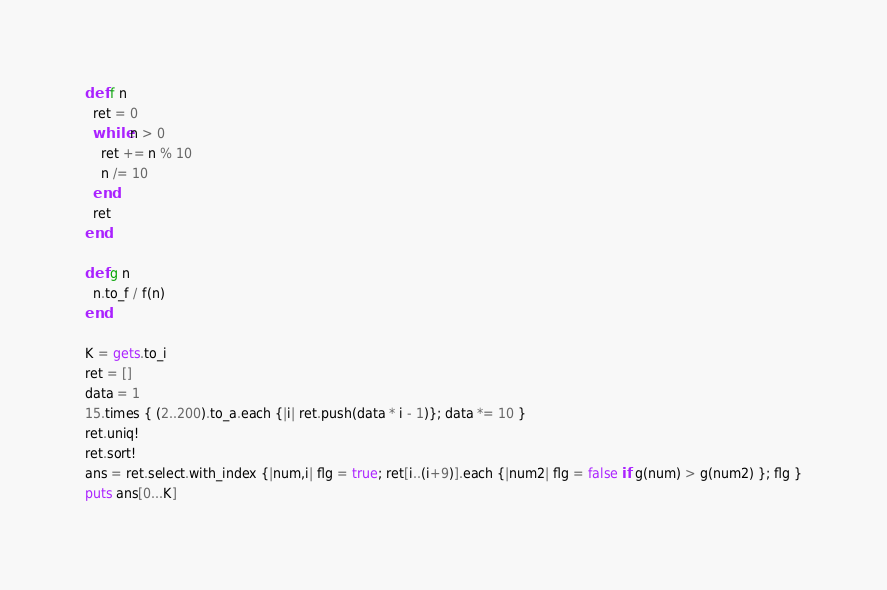Convert code to text. <code><loc_0><loc_0><loc_500><loc_500><_Ruby_>def f n
  ret = 0
  while n > 0
    ret += n % 10
    n /= 10
  end
  ret
end

def g n
  n.to_f / f(n)
end

K = gets.to_i
ret = []
data = 1
15.times { (2..200).to_a.each {|i| ret.push(data * i - 1)}; data *= 10 }
ret.uniq!
ret.sort!
ans = ret.select.with_index {|num,i| flg = true; ret[i..(i+9)].each {|num2| flg = false if g(num) > g(num2) }; flg }
puts ans[0...K]</code> 